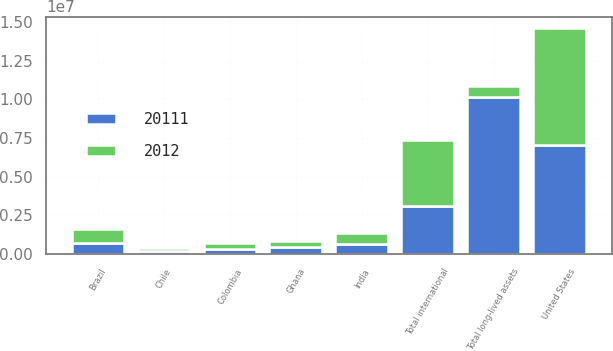<chart> <loc_0><loc_0><loc_500><loc_500><stacked_bar_chart><ecel><fcel>United States<fcel>Brazil<fcel>Chile<fcel>Colombia<fcel>Ghana<fcel>India<fcel>Total international<fcel>Total long-lived assets<nl><fcel>2012<fcel>7.55808e+06<fcel>909330<fcel>196387<fcel>380326<fcel>377553<fcel>676049<fcel>4.25902e+06<fcel>676049<nl><fcel>20111<fcel>7.0536e+06<fcel>695923<fcel>178670<fcel>316096<fcel>427759<fcel>671091<fcel>3.09947e+06<fcel>1.01531e+07<nl></chart> 